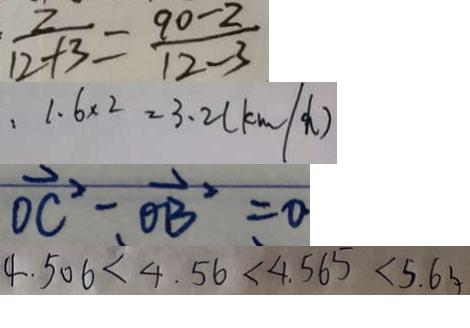Convert formula to latex. <formula><loc_0><loc_0><loc_500><loc_500>\frac { 2 } { 1 2 + 3 } = \frac { 9 0 - 2 } { 1 2 - 3 } 
 . 1 . 6 \times 2 = 3 . 2 ( k m \div h ) 
 \overrightarrow { O C ^ { 2 } } - \overrightarrow { O B ^ { 2 } } = 0 
 4 . 5 0 6 < 4 . 5 6 < 4 . 5 6 5 < 5 . 6 3</formula> 